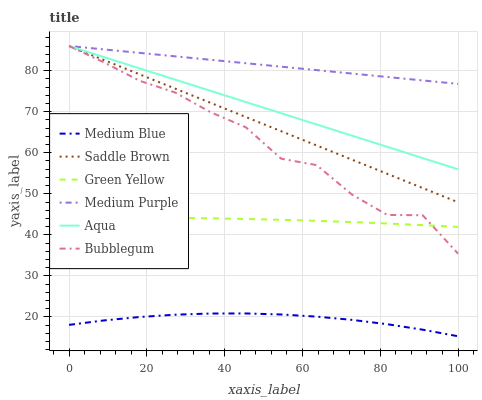Does Medium Blue have the minimum area under the curve?
Answer yes or no. Yes. Does Medium Purple have the maximum area under the curve?
Answer yes or no. Yes. Does Aqua have the minimum area under the curve?
Answer yes or no. No. Does Aqua have the maximum area under the curve?
Answer yes or no. No. Is Medium Purple the smoothest?
Answer yes or no. Yes. Is Bubblegum the roughest?
Answer yes or no. Yes. Is Aqua the smoothest?
Answer yes or no. No. Is Aqua the roughest?
Answer yes or no. No. Does Medium Blue have the lowest value?
Answer yes or no. Yes. Does Aqua have the lowest value?
Answer yes or no. No. Does Saddle Brown have the highest value?
Answer yes or no. Yes. Does Green Yellow have the highest value?
Answer yes or no. No. Is Medium Blue less than Bubblegum?
Answer yes or no. Yes. Is Aqua greater than Medium Blue?
Answer yes or no. Yes. Does Medium Purple intersect Saddle Brown?
Answer yes or no. Yes. Is Medium Purple less than Saddle Brown?
Answer yes or no. No. Is Medium Purple greater than Saddle Brown?
Answer yes or no. No. Does Medium Blue intersect Bubblegum?
Answer yes or no. No. 